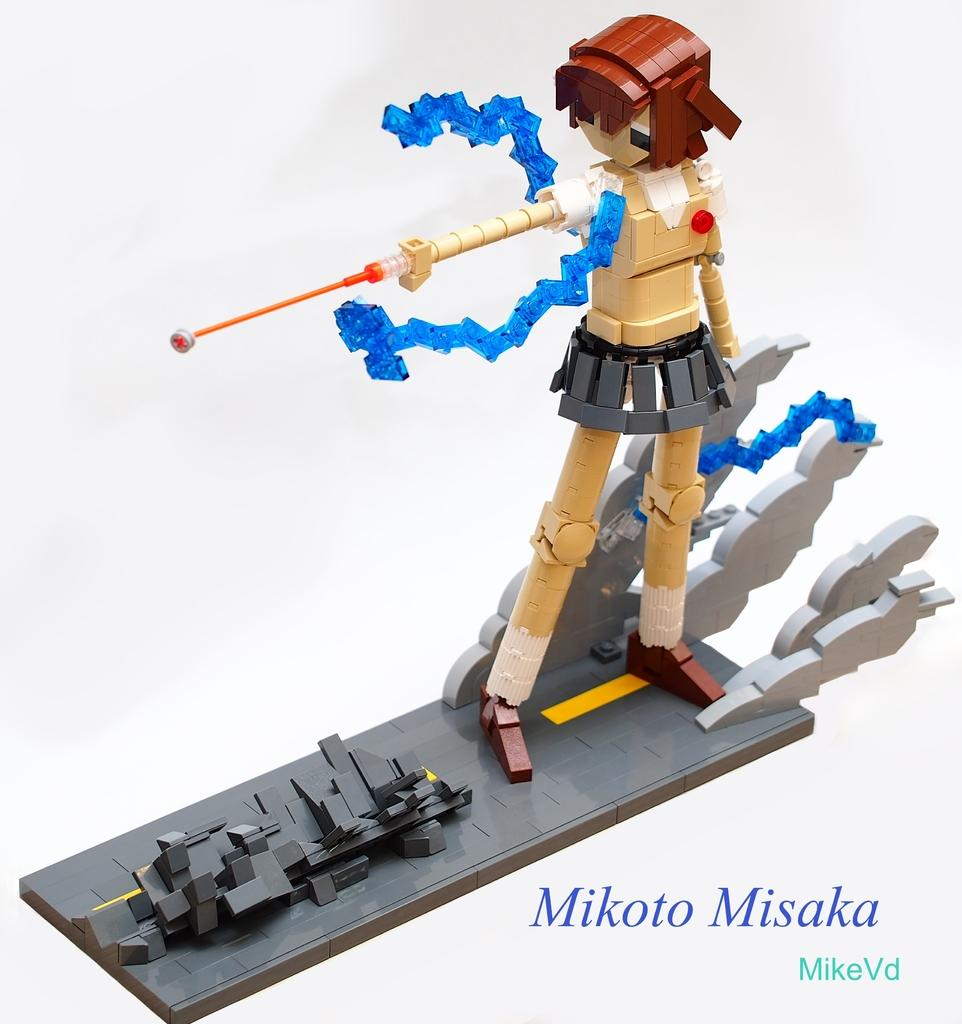What is the main subject of the image? The main subject of the image is a toy of a girl. Is there any text present in the image? Yes, there is text written on the image. How many beds are visible in the image? There are no beds present in the image. 